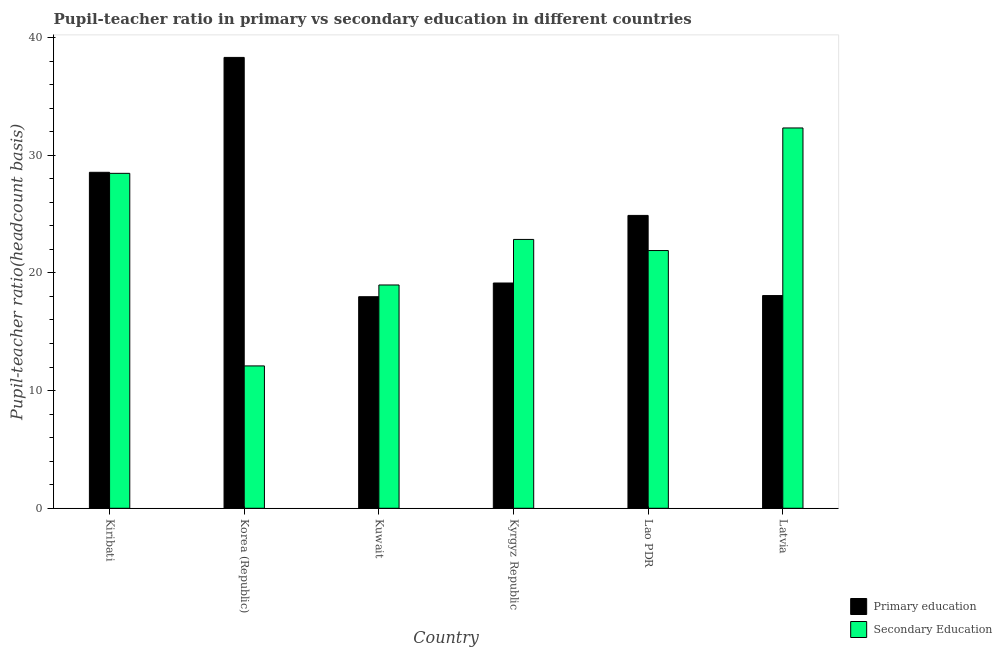How many groups of bars are there?
Your answer should be very brief. 6. Are the number of bars on each tick of the X-axis equal?
Provide a short and direct response. Yes. How many bars are there on the 2nd tick from the right?
Your answer should be very brief. 2. What is the label of the 4th group of bars from the left?
Ensure brevity in your answer.  Kyrgyz Republic. In how many cases, is the number of bars for a given country not equal to the number of legend labels?
Your response must be concise. 0. What is the pupil teacher ratio on secondary education in Kuwait?
Offer a terse response. 18.97. Across all countries, what is the maximum pupil-teacher ratio in primary education?
Your response must be concise. 38.31. Across all countries, what is the minimum pupil teacher ratio on secondary education?
Provide a succinct answer. 12.1. In which country was the pupil teacher ratio on secondary education maximum?
Keep it short and to the point. Latvia. In which country was the pupil teacher ratio on secondary education minimum?
Your answer should be compact. Korea (Republic). What is the total pupil-teacher ratio in primary education in the graph?
Offer a terse response. 146.92. What is the difference between the pupil teacher ratio on secondary education in Kiribati and that in Kuwait?
Provide a succinct answer. 9.49. What is the difference between the pupil teacher ratio on secondary education in Kyrgyz Republic and the pupil-teacher ratio in primary education in Latvia?
Offer a terse response. 4.77. What is the average pupil teacher ratio on secondary education per country?
Your response must be concise. 22.76. What is the difference between the pupil-teacher ratio in primary education and pupil teacher ratio on secondary education in Korea (Republic)?
Provide a succinct answer. 26.21. What is the ratio of the pupil-teacher ratio in primary education in Kiribati to that in Kyrgyz Republic?
Provide a short and direct response. 1.49. What is the difference between the highest and the second highest pupil-teacher ratio in primary education?
Ensure brevity in your answer.  9.76. What is the difference between the highest and the lowest pupil teacher ratio on secondary education?
Make the answer very short. 20.22. What does the 1st bar from the left in Korea (Republic) represents?
Offer a terse response. Primary education. What does the 1st bar from the right in Lao PDR represents?
Provide a short and direct response. Secondary Education. Are all the bars in the graph horizontal?
Your answer should be very brief. No. Where does the legend appear in the graph?
Give a very brief answer. Bottom right. How many legend labels are there?
Your answer should be very brief. 2. How are the legend labels stacked?
Provide a succinct answer. Vertical. What is the title of the graph?
Your answer should be very brief. Pupil-teacher ratio in primary vs secondary education in different countries. What is the label or title of the X-axis?
Ensure brevity in your answer.  Country. What is the label or title of the Y-axis?
Your answer should be very brief. Pupil-teacher ratio(headcount basis). What is the Pupil-teacher ratio(headcount basis) of Primary education in Kiribati?
Your answer should be compact. 28.55. What is the Pupil-teacher ratio(headcount basis) in Secondary Education in Kiribati?
Keep it short and to the point. 28.46. What is the Pupil-teacher ratio(headcount basis) of Primary education in Korea (Republic)?
Keep it short and to the point. 38.31. What is the Pupil-teacher ratio(headcount basis) of Secondary Education in Korea (Republic)?
Provide a short and direct response. 12.1. What is the Pupil-teacher ratio(headcount basis) of Primary education in Kuwait?
Your response must be concise. 17.98. What is the Pupil-teacher ratio(headcount basis) in Secondary Education in Kuwait?
Provide a succinct answer. 18.97. What is the Pupil-teacher ratio(headcount basis) in Primary education in Kyrgyz Republic?
Provide a short and direct response. 19.14. What is the Pupil-teacher ratio(headcount basis) in Secondary Education in Kyrgyz Republic?
Keep it short and to the point. 22.84. What is the Pupil-teacher ratio(headcount basis) of Primary education in Lao PDR?
Provide a short and direct response. 24.88. What is the Pupil-teacher ratio(headcount basis) in Secondary Education in Lao PDR?
Keep it short and to the point. 21.9. What is the Pupil-teacher ratio(headcount basis) of Primary education in Latvia?
Your response must be concise. 18.07. What is the Pupil-teacher ratio(headcount basis) of Secondary Education in Latvia?
Your answer should be compact. 32.31. Across all countries, what is the maximum Pupil-teacher ratio(headcount basis) of Primary education?
Your answer should be compact. 38.31. Across all countries, what is the maximum Pupil-teacher ratio(headcount basis) in Secondary Education?
Ensure brevity in your answer.  32.31. Across all countries, what is the minimum Pupil-teacher ratio(headcount basis) in Primary education?
Provide a short and direct response. 17.98. Across all countries, what is the minimum Pupil-teacher ratio(headcount basis) in Secondary Education?
Keep it short and to the point. 12.1. What is the total Pupil-teacher ratio(headcount basis) of Primary education in the graph?
Your answer should be compact. 146.92. What is the total Pupil-teacher ratio(headcount basis) in Secondary Education in the graph?
Ensure brevity in your answer.  136.58. What is the difference between the Pupil-teacher ratio(headcount basis) in Primary education in Kiribati and that in Korea (Republic)?
Offer a terse response. -9.76. What is the difference between the Pupil-teacher ratio(headcount basis) of Secondary Education in Kiribati and that in Korea (Republic)?
Provide a succinct answer. 16.36. What is the difference between the Pupil-teacher ratio(headcount basis) in Primary education in Kiribati and that in Kuwait?
Offer a very short reply. 10.57. What is the difference between the Pupil-teacher ratio(headcount basis) in Secondary Education in Kiribati and that in Kuwait?
Provide a succinct answer. 9.49. What is the difference between the Pupil-teacher ratio(headcount basis) of Primary education in Kiribati and that in Kyrgyz Republic?
Your response must be concise. 9.41. What is the difference between the Pupil-teacher ratio(headcount basis) in Secondary Education in Kiribati and that in Kyrgyz Republic?
Make the answer very short. 5.62. What is the difference between the Pupil-teacher ratio(headcount basis) in Primary education in Kiribati and that in Lao PDR?
Your answer should be compact. 3.66. What is the difference between the Pupil-teacher ratio(headcount basis) in Secondary Education in Kiribati and that in Lao PDR?
Offer a terse response. 6.56. What is the difference between the Pupil-teacher ratio(headcount basis) of Primary education in Kiribati and that in Latvia?
Offer a very short reply. 10.47. What is the difference between the Pupil-teacher ratio(headcount basis) of Secondary Education in Kiribati and that in Latvia?
Provide a succinct answer. -3.86. What is the difference between the Pupil-teacher ratio(headcount basis) in Primary education in Korea (Republic) and that in Kuwait?
Keep it short and to the point. 20.33. What is the difference between the Pupil-teacher ratio(headcount basis) of Secondary Education in Korea (Republic) and that in Kuwait?
Give a very brief answer. -6.88. What is the difference between the Pupil-teacher ratio(headcount basis) in Primary education in Korea (Republic) and that in Kyrgyz Republic?
Your response must be concise. 19.17. What is the difference between the Pupil-teacher ratio(headcount basis) of Secondary Education in Korea (Republic) and that in Kyrgyz Republic?
Your answer should be very brief. -10.75. What is the difference between the Pupil-teacher ratio(headcount basis) of Primary education in Korea (Republic) and that in Lao PDR?
Your response must be concise. 13.42. What is the difference between the Pupil-teacher ratio(headcount basis) in Secondary Education in Korea (Republic) and that in Lao PDR?
Make the answer very short. -9.8. What is the difference between the Pupil-teacher ratio(headcount basis) of Primary education in Korea (Republic) and that in Latvia?
Provide a succinct answer. 20.24. What is the difference between the Pupil-teacher ratio(headcount basis) in Secondary Education in Korea (Republic) and that in Latvia?
Offer a terse response. -20.22. What is the difference between the Pupil-teacher ratio(headcount basis) in Primary education in Kuwait and that in Kyrgyz Republic?
Offer a very short reply. -1.16. What is the difference between the Pupil-teacher ratio(headcount basis) in Secondary Education in Kuwait and that in Kyrgyz Republic?
Provide a short and direct response. -3.87. What is the difference between the Pupil-teacher ratio(headcount basis) of Primary education in Kuwait and that in Lao PDR?
Your answer should be compact. -6.91. What is the difference between the Pupil-teacher ratio(headcount basis) of Secondary Education in Kuwait and that in Lao PDR?
Your answer should be very brief. -2.93. What is the difference between the Pupil-teacher ratio(headcount basis) of Primary education in Kuwait and that in Latvia?
Offer a terse response. -0.1. What is the difference between the Pupil-teacher ratio(headcount basis) of Secondary Education in Kuwait and that in Latvia?
Give a very brief answer. -13.34. What is the difference between the Pupil-teacher ratio(headcount basis) in Primary education in Kyrgyz Republic and that in Lao PDR?
Your answer should be very brief. -5.74. What is the difference between the Pupil-teacher ratio(headcount basis) in Secondary Education in Kyrgyz Republic and that in Lao PDR?
Make the answer very short. 0.94. What is the difference between the Pupil-teacher ratio(headcount basis) in Primary education in Kyrgyz Republic and that in Latvia?
Offer a terse response. 1.07. What is the difference between the Pupil-teacher ratio(headcount basis) in Secondary Education in Kyrgyz Republic and that in Latvia?
Keep it short and to the point. -9.47. What is the difference between the Pupil-teacher ratio(headcount basis) in Primary education in Lao PDR and that in Latvia?
Make the answer very short. 6.81. What is the difference between the Pupil-teacher ratio(headcount basis) in Secondary Education in Lao PDR and that in Latvia?
Make the answer very short. -10.42. What is the difference between the Pupil-teacher ratio(headcount basis) in Primary education in Kiribati and the Pupil-teacher ratio(headcount basis) in Secondary Education in Korea (Republic)?
Keep it short and to the point. 16.45. What is the difference between the Pupil-teacher ratio(headcount basis) of Primary education in Kiribati and the Pupil-teacher ratio(headcount basis) of Secondary Education in Kuwait?
Keep it short and to the point. 9.57. What is the difference between the Pupil-teacher ratio(headcount basis) of Primary education in Kiribati and the Pupil-teacher ratio(headcount basis) of Secondary Education in Kyrgyz Republic?
Offer a very short reply. 5.7. What is the difference between the Pupil-teacher ratio(headcount basis) in Primary education in Kiribati and the Pupil-teacher ratio(headcount basis) in Secondary Education in Lao PDR?
Offer a terse response. 6.65. What is the difference between the Pupil-teacher ratio(headcount basis) in Primary education in Kiribati and the Pupil-teacher ratio(headcount basis) in Secondary Education in Latvia?
Your response must be concise. -3.77. What is the difference between the Pupil-teacher ratio(headcount basis) in Primary education in Korea (Republic) and the Pupil-teacher ratio(headcount basis) in Secondary Education in Kuwait?
Your answer should be compact. 19.33. What is the difference between the Pupil-teacher ratio(headcount basis) of Primary education in Korea (Republic) and the Pupil-teacher ratio(headcount basis) of Secondary Education in Kyrgyz Republic?
Your answer should be very brief. 15.46. What is the difference between the Pupil-teacher ratio(headcount basis) of Primary education in Korea (Republic) and the Pupil-teacher ratio(headcount basis) of Secondary Education in Lao PDR?
Ensure brevity in your answer.  16.41. What is the difference between the Pupil-teacher ratio(headcount basis) of Primary education in Korea (Republic) and the Pupil-teacher ratio(headcount basis) of Secondary Education in Latvia?
Provide a short and direct response. 5.99. What is the difference between the Pupil-teacher ratio(headcount basis) in Primary education in Kuwait and the Pupil-teacher ratio(headcount basis) in Secondary Education in Kyrgyz Republic?
Keep it short and to the point. -4.87. What is the difference between the Pupil-teacher ratio(headcount basis) in Primary education in Kuwait and the Pupil-teacher ratio(headcount basis) in Secondary Education in Lao PDR?
Provide a succinct answer. -3.92. What is the difference between the Pupil-teacher ratio(headcount basis) of Primary education in Kuwait and the Pupil-teacher ratio(headcount basis) of Secondary Education in Latvia?
Give a very brief answer. -14.34. What is the difference between the Pupil-teacher ratio(headcount basis) of Primary education in Kyrgyz Republic and the Pupil-teacher ratio(headcount basis) of Secondary Education in Lao PDR?
Your answer should be compact. -2.76. What is the difference between the Pupil-teacher ratio(headcount basis) of Primary education in Kyrgyz Republic and the Pupil-teacher ratio(headcount basis) of Secondary Education in Latvia?
Make the answer very short. -13.17. What is the difference between the Pupil-teacher ratio(headcount basis) in Primary education in Lao PDR and the Pupil-teacher ratio(headcount basis) in Secondary Education in Latvia?
Your answer should be very brief. -7.43. What is the average Pupil-teacher ratio(headcount basis) in Primary education per country?
Offer a very short reply. 24.49. What is the average Pupil-teacher ratio(headcount basis) in Secondary Education per country?
Ensure brevity in your answer.  22.76. What is the difference between the Pupil-teacher ratio(headcount basis) in Primary education and Pupil-teacher ratio(headcount basis) in Secondary Education in Kiribati?
Your answer should be very brief. 0.09. What is the difference between the Pupil-teacher ratio(headcount basis) in Primary education and Pupil-teacher ratio(headcount basis) in Secondary Education in Korea (Republic)?
Offer a very short reply. 26.21. What is the difference between the Pupil-teacher ratio(headcount basis) of Primary education and Pupil-teacher ratio(headcount basis) of Secondary Education in Kuwait?
Keep it short and to the point. -1. What is the difference between the Pupil-teacher ratio(headcount basis) of Primary education and Pupil-teacher ratio(headcount basis) of Secondary Education in Kyrgyz Republic?
Provide a short and direct response. -3.7. What is the difference between the Pupil-teacher ratio(headcount basis) in Primary education and Pupil-teacher ratio(headcount basis) in Secondary Education in Lao PDR?
Provide a short and direct response. 2.98. What is the difference between the Pupil-teacher ratio(headcount basis) in Primary education and Pupil-teacher ratio(headcount basis) in Secondary Education in Latvia?
Ensure brevity in your answer.  -14.24. What is the ratio of the Pupil-teacher ratio(headcount basis) in Primary education in Kiribati to that in Korea (Republic)?
Your answer should be compact. 0.75. What is the ratio of the Pupil-teacher ratio(headcount basis) of Secondary Education in Kiribati to that in Korea (Republic)?
Give a very brief answer. 2.35. What is the ratio of the Pupil-teacher ratio(headcount basis) in Primary education in Kiribati to that in Kuwait?
Keep it short and to the point. 1.59. What is the ratio of the Pupil-teacher ratio(headcount basis) in Primary education in Kiribati to that in Kyrgyz Republic?
Give a very brief answer. 1.49. What is the ratio of the Pupil-teacher ratio(headcount basis) in Secondary Education in Kiribati to that in Kyrgyz Republic?
Make the answer very short. 1.25. What is the ratio of the Pupil-teacher ratio(headcount basis) in Primary education in Kiribati to that in Lao PDR?
Offer a terse response. 1.15. What is the ratio of the Pupil-teacher ratio(headcount basis) of Secondary Education in Kiribati to that in Lao PDR?
Offer a terse response. 1.3. What is the ratio of the Pupil-teacher ratio(headcount basis) in Primary education in Kiribati to that in Latvia?
Ensure brevity in your answer.  1.58. What is the ratio of the Pupil-teacher ratio(headcount basis) of Secondary Education in Kiribati to that in Latvia?
Your response must be concise. 0.88. What is the ratio of the Pupil-teacher ratio(headcount basis) in Primary education in Korea (Republic) to that in Kuwait?
Give a very brief answer. 2.13. What is the ratio of the Pupil-teacher ratio(headcount basis) of Secondary Education in Korea (Republic) to that in Kuwait?
Your answer should be very brief. 0.64. What is the ratio of the Pupil-teacher ratio(headcount basis) in Primary education in Korea (Republic) to that in Kyrgyz Republic?
Give a very brief answer. 2. What is the ratio of the Pupil-teacher ratio(headcount basis) in Secondary Education in Korea (Republic) to that in Kyrgyz Republic?
Give a very brief answer. 0.53. What is the ratio of the Pupil-teacher ratio(headcount basis) of Primary education in Korea (Republic) to that in Lao PDR?
Provide a succinct answer. 1.54. What is the ratio of the Pupil-teacher ratio(headcount basis) in Secondary Education in Korea (Republic) to that in Lao PDR?
Give a very brief answer. 0.55. What is the ratio of the Pupil-teacher ratio(headcount basis) in Primary education in Korea (Republic) to that in Latvia?
Keep it short and to the point. 2.12. What is the ratio of the Pupil-teacher ratio(headcount basis) in Secondary Education in Korea (Republic) to that in Latvia?
Provide a short and direct response. 0.37. What is the ratio of the Pupil-teacher ratio(headcount basis) of Primary education in Kuwait to that in Kyrgyz Republic?
Give a very brief answer. 0.94. What is the ratio of the Pupil-teacher ratio(headcount basis) of Secondary Education in Kuwait to that in Kyrgyz Republic?
Your answer should be very brief. 0.83. What is the ratio of the Pupil-teacher ratio(headcount basis) in Primary education in Kuwait to that in Lao PDR?
Ensure brevity in your answer.  0.72. What is the ratio of the Pupil-teacher ratio(headcount basis) in Secondary Education in Kuwait to that in Lao PDR?
Give a very brief answer. 0.87. What is the ratio of the Pupil-teacher ratio(headcount basis) in Secondary Education in Kuwait to that in Latvia?
Keep it short and to the point. 0.59. What is the ratio of the Pupil-teacher ratio(headcount basis) in Primary education in Kyrgyz Republic to that in Lao PDR?
Offer a very short reply. 0.77. What is the ratio of the Pupil-teacher ratio(headcount basis) of Secondary Education in Kyrgyz Republic to that in Lao PDR?
Give a very brief answer. 1.04. What is the ratio of the Pupil-teacher ratio(headcount basis) in Primary education in Kyrgyz Republic to that in Latvia?
Provide a short and direct response. 1.06. What is the ratio of the Pupil-teacher ratio(headcount basis) in Secondary Education in Kyrgyz Republic to that in Latvia?
Ensure brevity in your answer.  0.71. What is the ratio of the Pupil-teacher ratio(headcount basis) in Primary education in Lao PDR to that in Latvia?
Offer a very short reply. 1.38. What is the ratio of the Pupil-teacher ratio(headcount basis) of Secondary Education in Lao PDR to that in Latvia?
Your answer should be very brief. 0.68. What is the difference between the highest and the second highest Pupil-teacher ratio(headcount basis) in Primary education?
Provide a short and direct response. 9.76. What is the difference between the highest and the second highest Pupil-teacher ratio(headcount basis) of Secondary Education?
Provide a succinct answer. 3.86. What is the difference between the highest and the lowest Pupil-teacher ratio(headcount basis) in Primary education?
Provide a succinct answer. 20.33. What is the difference between the highest and the lowest Pupil-teacher ratio(headcount basis) of Secondary Education?
Provide a succinct answer. 20.22. 